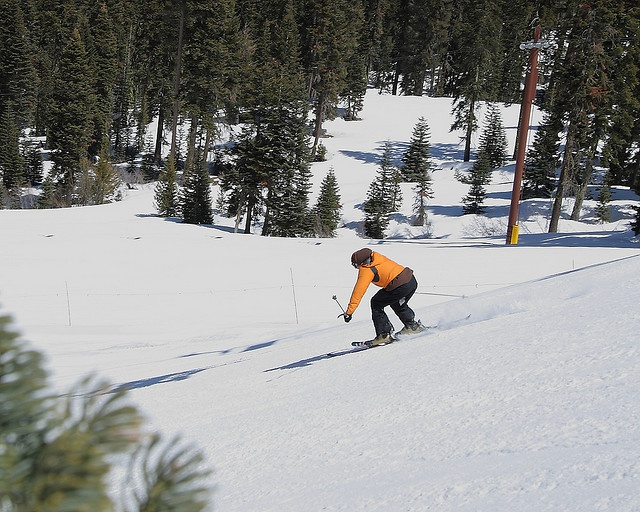Describe the objects in this image and their specific colors. I can see people in black, gray, lightgray, and orange tones and skis in black, lightgray, and darkgray tones in this image. 